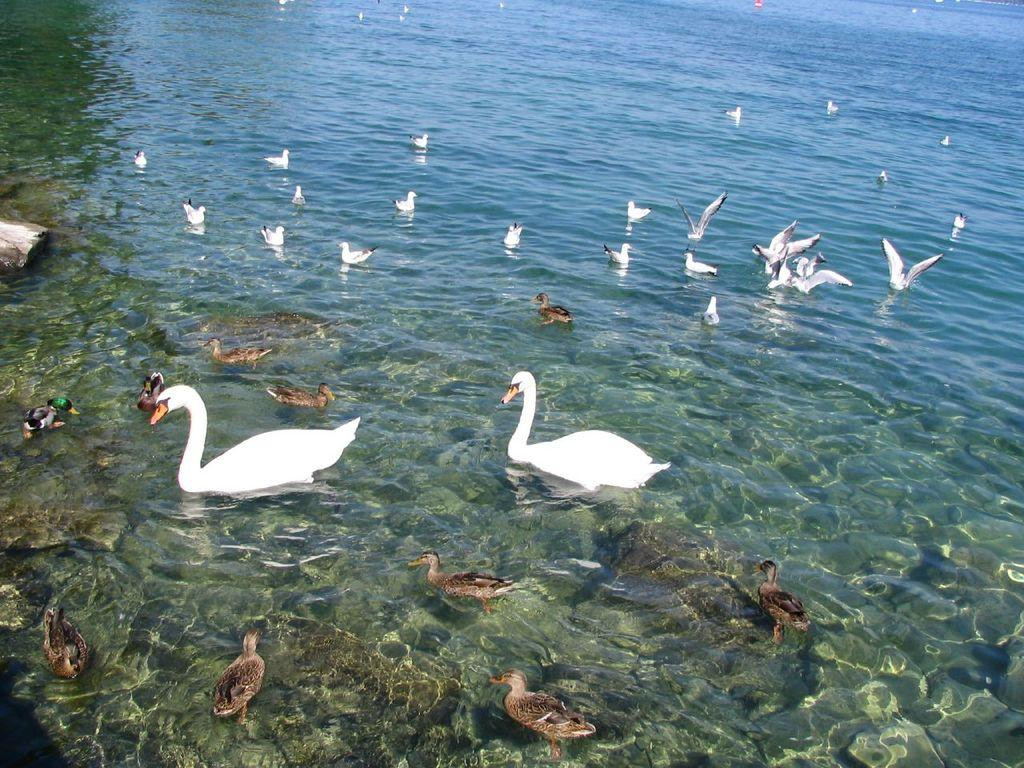What type of animals can be seen in the image? There are birds in the image. Can you identify a specific type of bird in the image? Yes, there are swans in the image. Where are the birds and swans located in the image? The birds and swans are in the water. What tools does the carpenter use to build a nest for the swans in the image? There is no carpenter present in the image, and swans typically build their own nests using natural materials. 